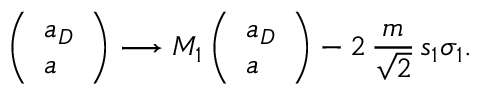<formula> <loc_0><loc_0><loc_500><loc_500>\left ( \begin{array} { l } { { a _ { D } } } \\ { a } \end{array} \right ) \longrightarrow M _ { 1 } \left ( \begin{array} { l } { { a _ { D } } } \\ { a } \end{array} \right ) - 2 \, { \frac { m } { \sqrt { 2 } } } \, s _ { 1 } \sigma _ { 1 } .</formula> 